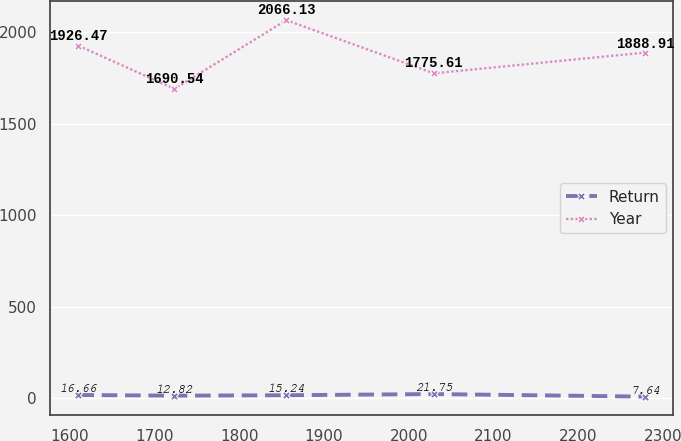<chart> <loc_0><loc_0><loc_500><loc_500><line_chart><ecel><fcel>Return<fcel>Year<nl><fcel>1610.03<fcel>16.66<fcel>1926.47<nl><fcel>1723.36<fcel>12.82<fcel>1690.54<nl><fcel>1855.45<fcel>15.24<fcel>2066.13<nl><fcel>2029.63<fcel>21.75<fcel>1775.61<nl><fcel>2279.08<fcel>7.64<fcel>1888.91<nl></chart> 